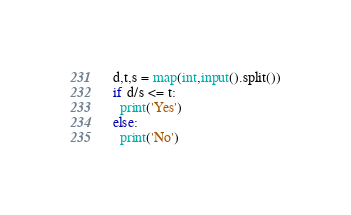<code> <loc_0><loc_0><loc_500><loc_500><_Python_>d,t,s = map(int,input().split())
if d/s <= t:
  print('Yes')
else:
  print('No')</code> 